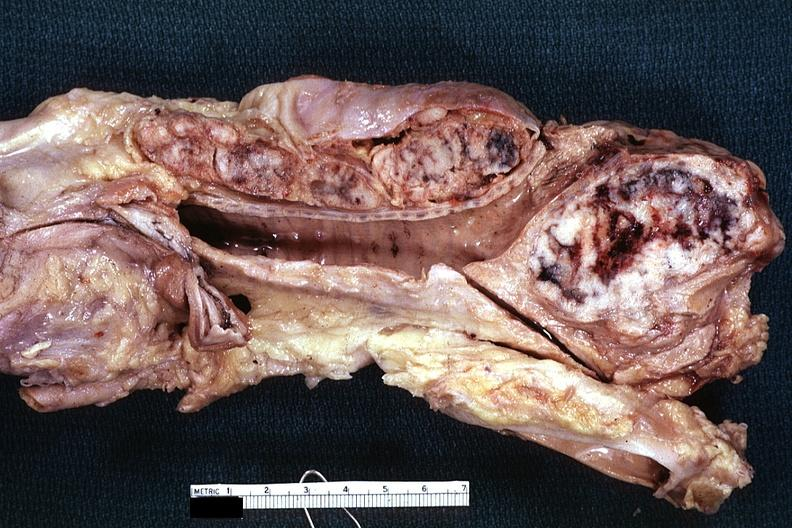what is present?
Answer the question using a single word or phrase. Lymph node 